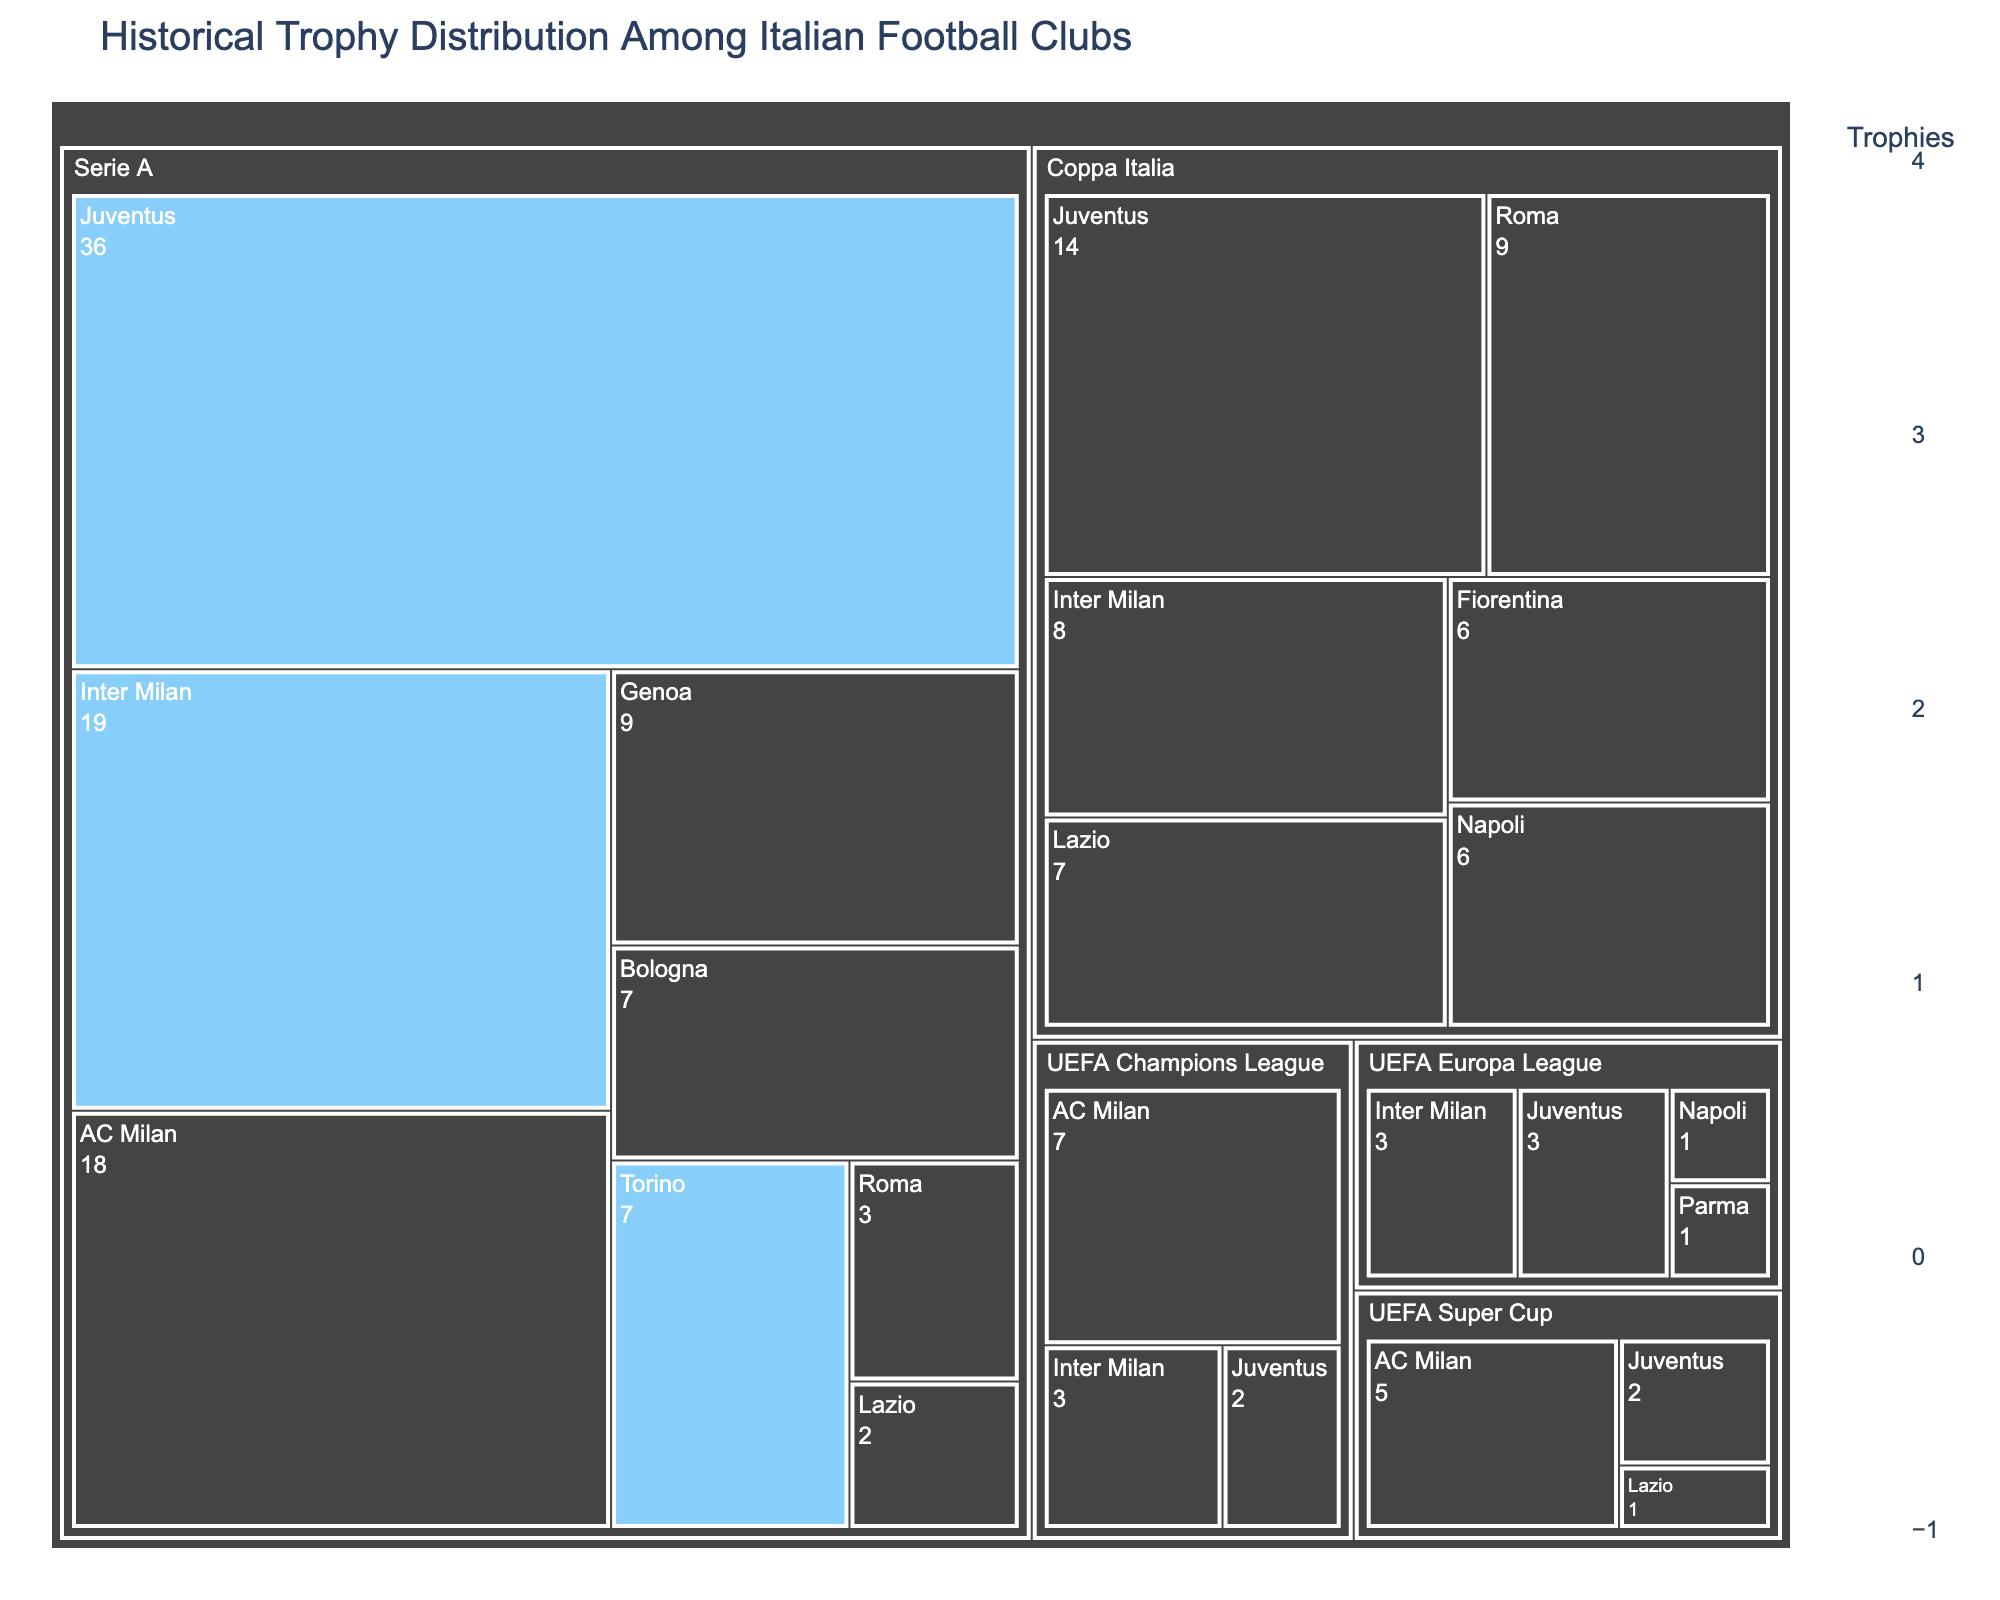What's the title of the figure? The title of the figure is typically placed at the top of the visualization and provides an overview of the chart's content. In this case, it is "Historical Trophy Distribution Among Italian Football Clubs".
Answer: Historical Trophy Distribution Among Italian Football Clubs Which club has the most Serie A trophies? To find this, look at the club with the largest section within the Serie A category of the treemap. Juventus has the most Serie A trophies with 36.
Answer: Juventus How many Coppa Italia trophies does Lazio have? Within the Coppa Italia section, identify Lazio. The visualization highlights Lazio's trophies, which are 7.
Answer: 7 Which competitions has Lazio won trophies in? Look at all the competition categories and identify where Lazio appears. Lazio has trophies in Serie A, Coppa Italia, and the UEFA Super Cup.
Answer: Serie A, Coppa Italia, UEFA Super Cup Compare the number of Serie A trophies between Lazio and Roma. Look within the Serie A category and compare the sections for Lazio and Roma. Lazio has 2 Serie A trophies, while Roma has 3.
Answer: Roma has 1 more than Lazio What's the total number of trophies won by AC Milan across all competitions? Sum the trophies across all competitions where AC Milan appears. In Serie A they have 18, in the UEFA Champions League they have 7, and in the UEFA Super Cup they have 5. So, total = 18 + 7 + 5 = 30.
Answer: 30 Which club has more UEFA Champions League trophies, Juventus or AC Milan? Within the UEFA Champions League category, compare the sections for Juventus and AC Milan. AC Milan has 7 trophies, while Juventus has 2.
Answer: AC Milan How many clubs have won the UEFA Europa League? Within the UEFA Europa League category, count the unique clubs listed. Juventus, Inter Milan, Parma, and Napoli have all won this competition.
Answer: 4 What's the difference in the number of Coppa Italia trophies between Juventus and Napoli? In the Coppa Italia section, compare the trophies of Juventus (14) and Napoli (6). The difference is 14 - 6 = 8.
Answer: 8 Describe the color scheme used for Lazio in this figure. The figure uses a blue scale for the trophies, and Lazio is specifically highlighted in a light blue color, differentiating it from other clubs. This helps in easily identifying Lazio's achievements.
Answer: Light blue color scheme with white borders 